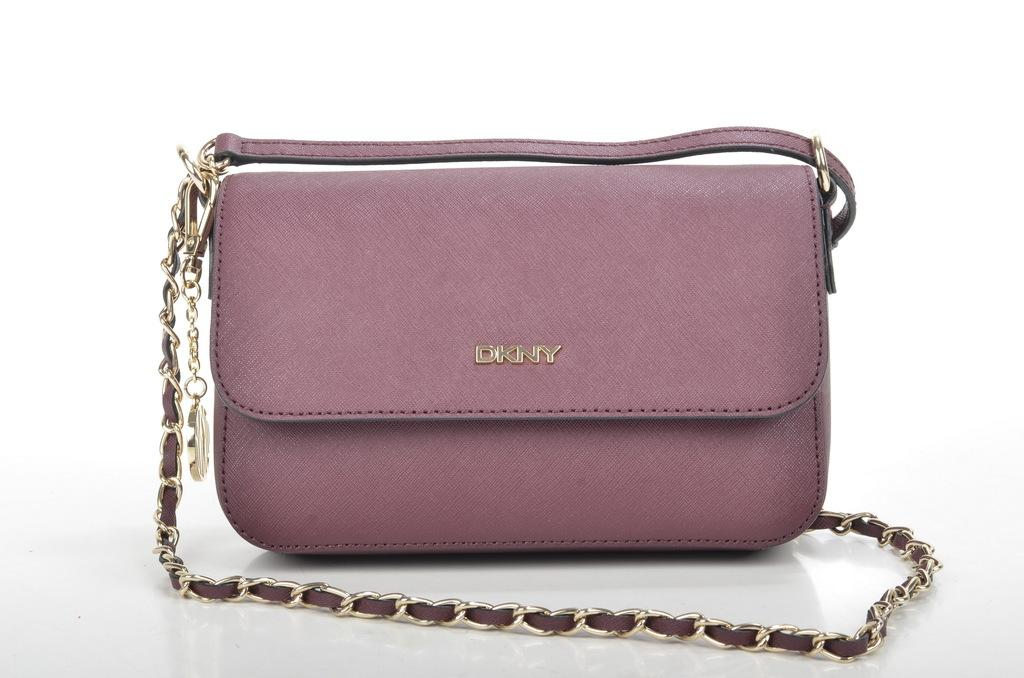What object can be seen in the image? There is a purse in the image. What is the color of the purse? The purse is maroon in color. What type of smell can be detected from the purse in the image? There is no information about the smell of the purse in the image, as it is a visual representation. 